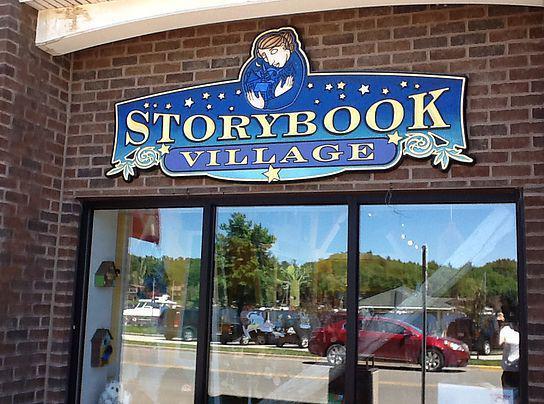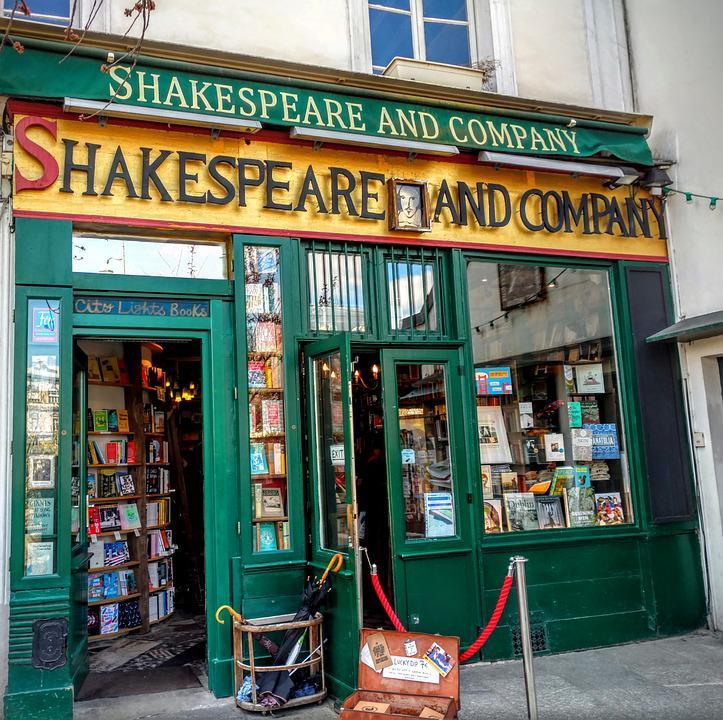The first image is the image on the left, the second image is the image on the right. For the images displayed, is the sentence "There are book shelves outside the store." factually correct? Answer yes or no. No. The first image is the image on the left, the second image is the image on the right. For the images shown, is this caption "In at least one image there is a woman with dark hair reading a book off to the left side of the outside of a bookstore with yellow trim." true? Answer yes or no. No. 